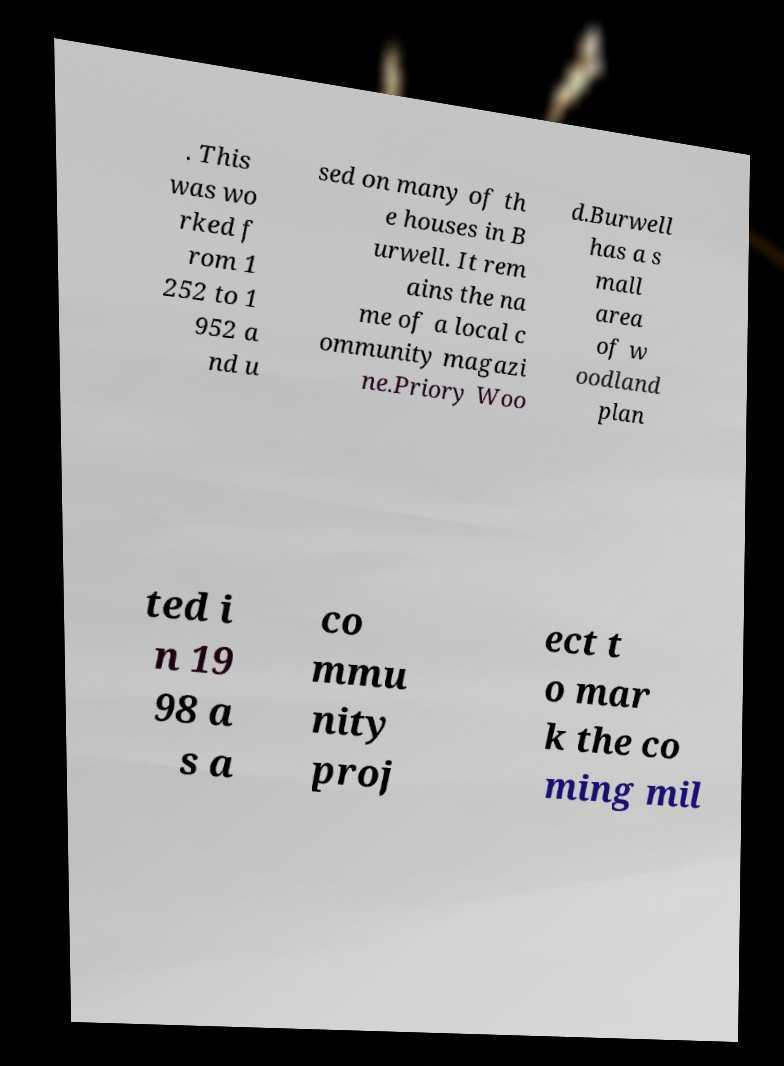There's text embedded in this image that I need extracted. Can you transcribe it verbatim? . This was wo rked f rom 1 252 to 1 952 a nd u sed on many of th e houses in B urwell. It rem ains the na me of a local c ommunity magazi ne.Priory Woo d.Burwell has a s mall area of w oodland plan ted i n 19 98 a s a co mmu nity proj ect t o mar k the co ming mil 